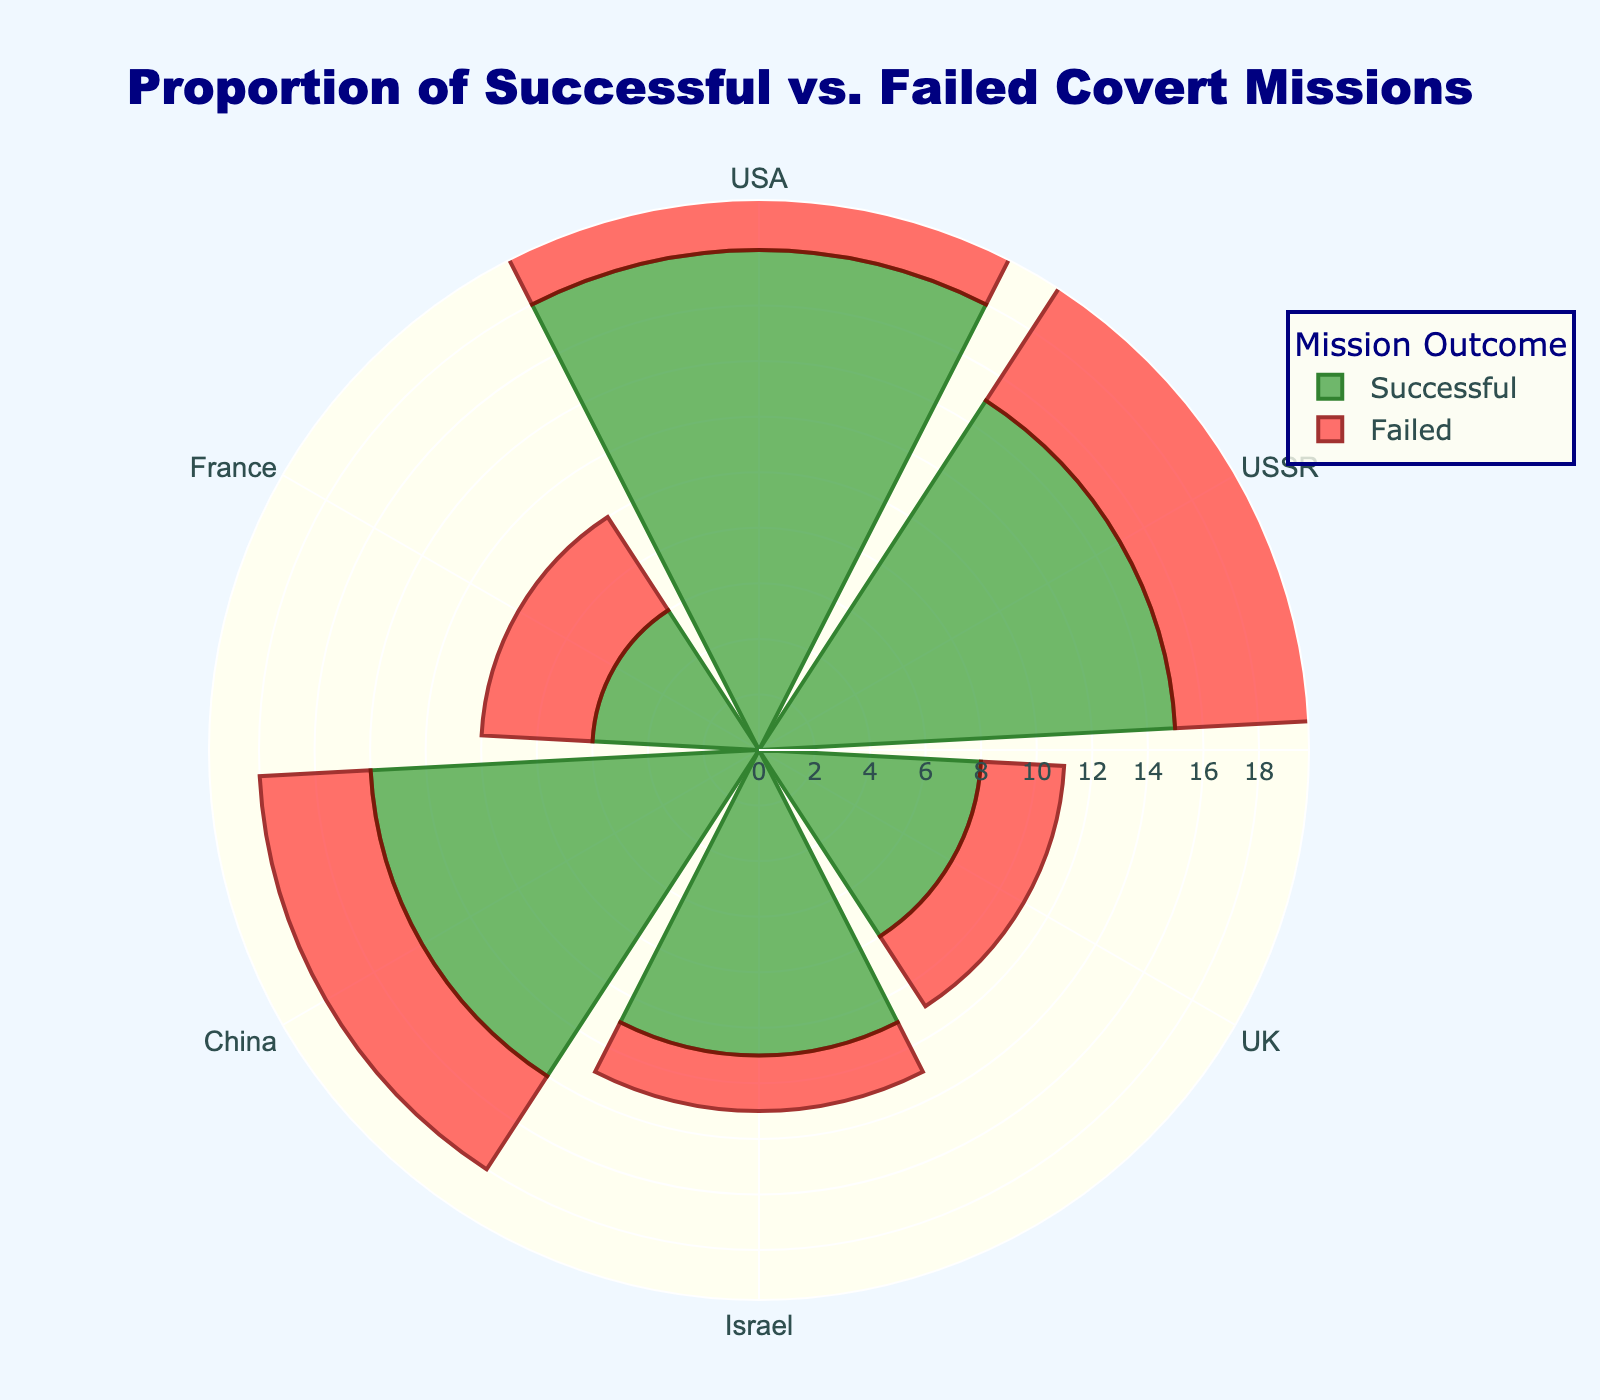what does the figure represent? The title of the figure states "Proportion of Successful vs. Failed Covert Missions," and the figure displays data from different countries. This suggests that the figure compares the counts of successful and failed covert missions across various countries.
Answer: Proportion of successful vs. failed covert missions in different countries What are the highest and lowest numbers of successful missions? We look at the bars representing successful missions (marked in green). The highest is for the USA (18 missions) and the lowest is for France (6 missions).
Answer: Highest: 18 (USA), Lowest: 6 (France) How many more successful missions did China have compared to the UK? China's bar for successful missions shows 14, and the UK's bar shows 8. Subtracting these gives us the difference.
Answer: 6 more missions Which country has the smallest difference between successful and failed missions? We need to calculate the difference between successful and failed missions for each country. France has the smallest difference with 2 (6 successful, 4 failed).
Answer: France Are there any countries where the number of failed missions is more than one-third of the number of successful missions? To check this, multiply the number of successful missions by 1/3 and compare it with the number of failed missions for each country. Countries where failed missions are more than one-third are the USA, USSR, China, and France.
Answer: USA, USSR, China, France What's the ratio of successful to failed missions in Israel? For Israel, there are 11 successful and 2 failed missions. The ratio is obtained by dividing successful by failed missions (11/2).
Answer: 5.5 Which country has the highest proportion of successful missions compared to total missions? To find the proportion, divide the number of successful missions by the sum of successful and failed missions for each country. Israel has the highest proportion with 11 successful out of a total of 13 missions.
Answer: Israel How many total missions did the UK conduct? The total number of missions can be found by adding successful and failed missions for the UK (8 + 3).
Answer: 11 For which country do successful missions exceed failed missions by the largest margin? We need to find the difference between successful and failed missions for each country. The USA has the largest margin with a difference of 11 (18 successful - 7 failed).
Answer: USA 